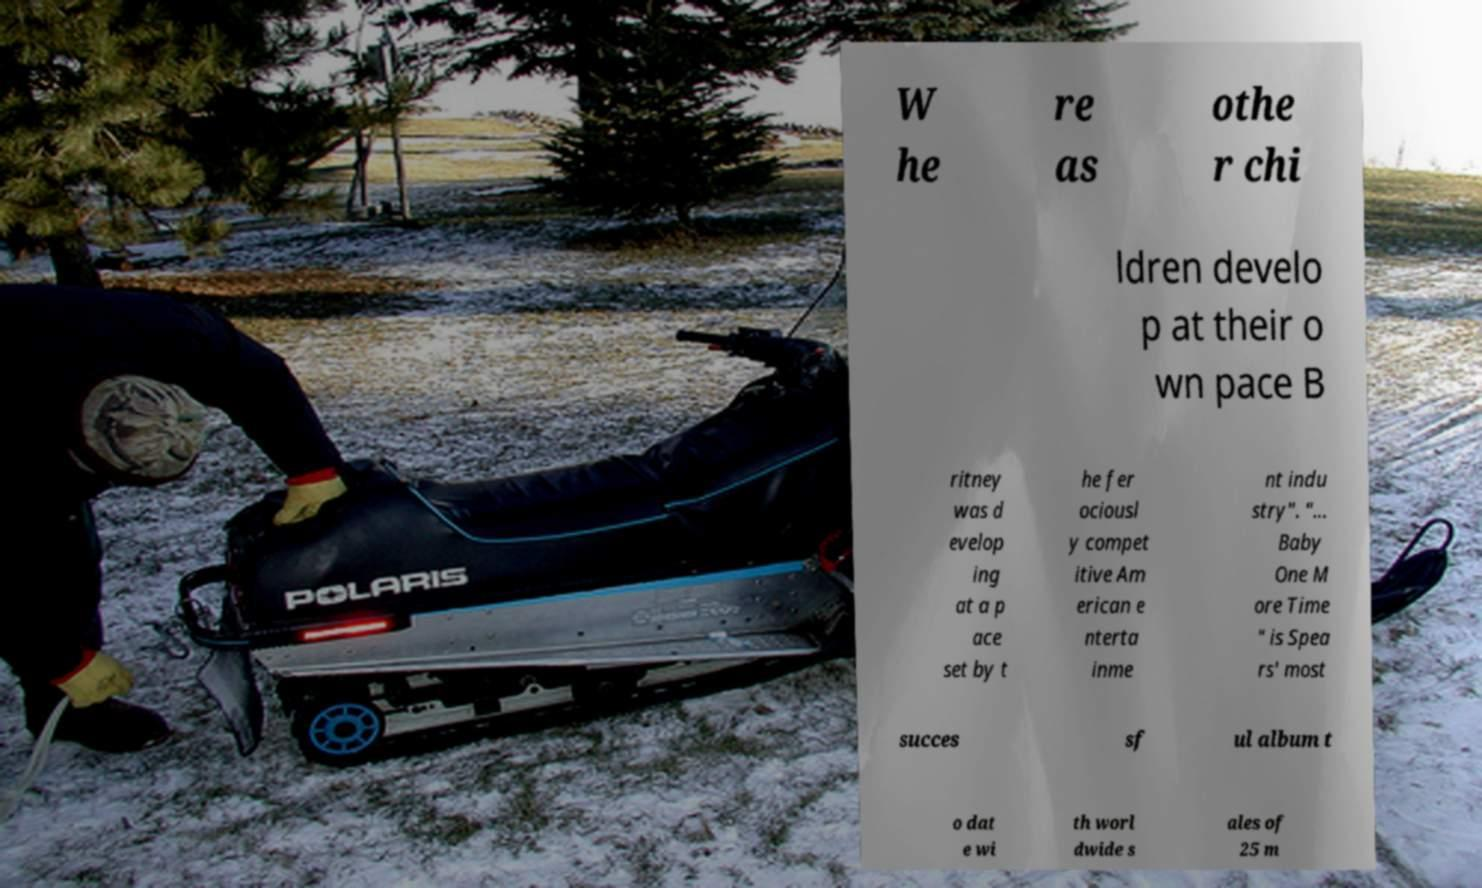Can you read and provide the text displayed in the image?This photo seems to have some interesting text. Can you extract and type it out for me? W he re as othe r chi ldren develo p at their o wn pace B ritney was d evelop ing at a p ace set by t he fer ociousl y compet itive Am erican e nterta inme nt indu stry". "... Baby One M ore Time " is Spea rs' most succes sf ul album t o dat e wi th worl dwide s ales of 25 m 